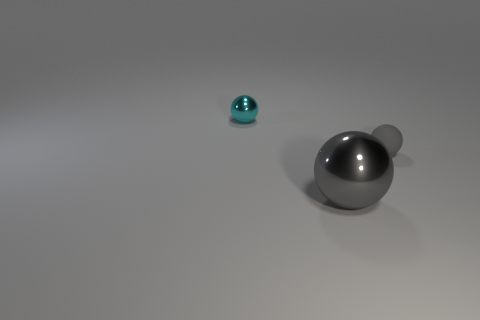Do the small rubber thing and the big sphere have the same color?
Your answer should be very brief. Yes. Are there any other things that are made of the same material as the small gray ball?
Keep it short and to the point. No. What material is the large thing that is the same color as the matte sphere?
Keep it short and to the point. Metal. How big is the cyan shiny object left of the gray object that is in front of the small thing right of the cyan sphere?
Ensure brevity in your answer.  Small. Are there fewer tiny blue matte blocks than cyan metallic objects?
Your response must be concise. Yes. There is another shiny object that is the same shape as the small cyan thing; what color is it?
Your answer should be compact. Gray. There is a tiny sphere to the left of the gray object that is left of the gray rubber sphere; is there a ball on the right side of it?
Provide a succinct answer. Yes. Are there fewer small cyan metal balls that are behind the small cyan metal object than small cyan metallic objects?
Ensure brevity in your answer.  Yes. There is a large sphere that is in front of the tiny ball in front of the sphere that is on the left side of the large sphere; what color is it?
Offer a very short reply. Gray. How many shiny objects are either tiny things or big gray objects?
Give a very brief answer. 2. 